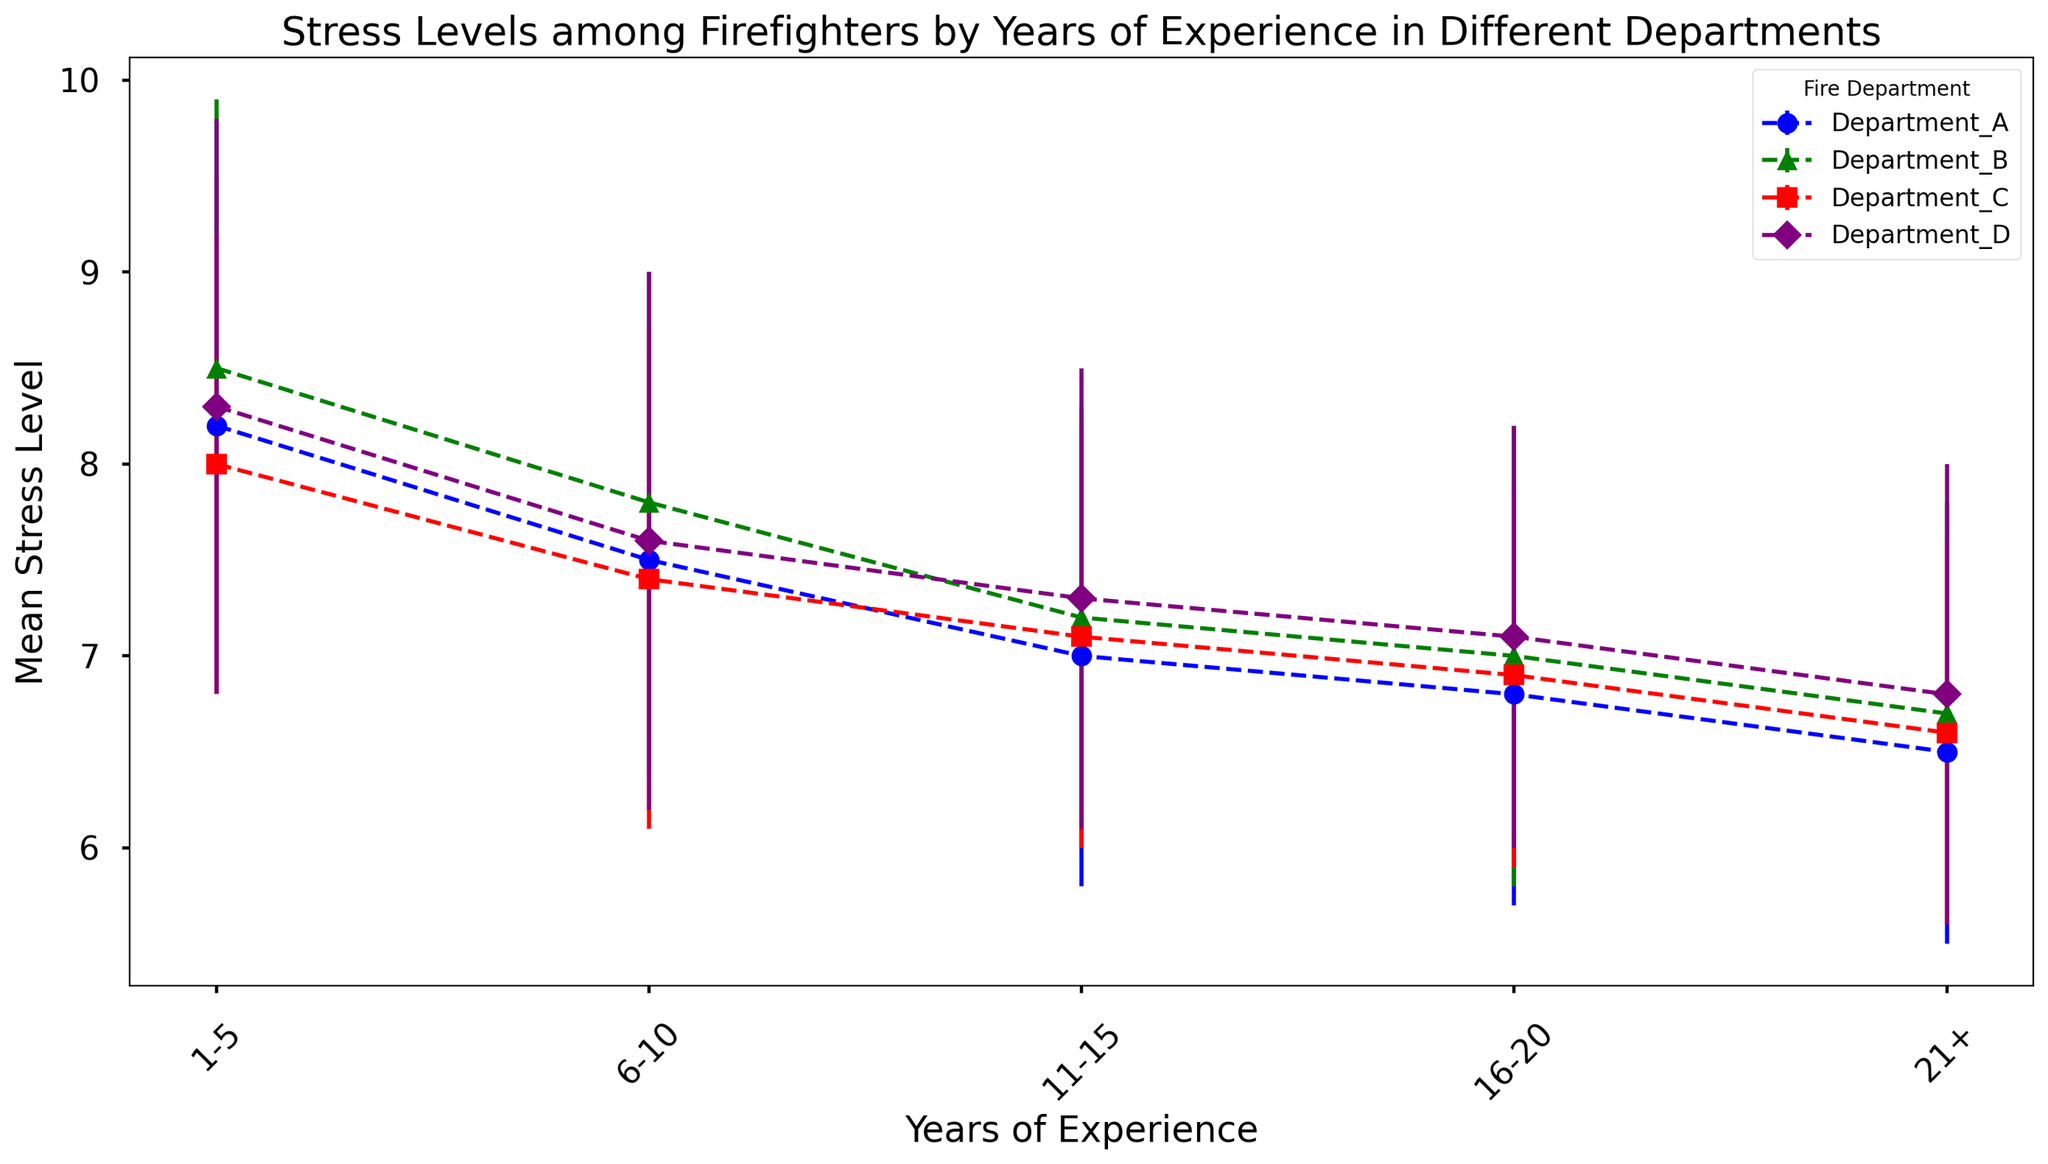How does the stress level of firefighters in Department A change with their years of experience? By looking at the trend in the data for Department A, the mean stress levels decrease from 8.2 to 6.5 as years of experience increase from 1-5 to 21+.
Answer: It decreases How does Department B's stress level for firefighters with 1-5 years of experience compare to Department C's for the same experience range? Compare the mean stress levels in the 1-5 years of experience category between the two departments: Department B has 8.5, while Department C has 8.0.
Answer: Department B's is higher For firefighters with 21+ years of experience, which department shows the lowest average stress level? Compare the mean stress levels for firefighters with 21+ years of experience across all departments. Department A has 6.5, Department B 6.7, Department C 6.6, and Department D 6.8.
Answer: Department A What is the difference in mean stress levels between the 1-5 years and 21+ years experience categories for Department D? Take the mean stress level for 1-5 years (8.3) and subtract the mean stress level for 21+ years (6.8) for Department D. 8.3 - 6.8 = 1.5.
Answer: 1.5 Which department exhibits the most significant decrease in stress levels from the 1-5 year range to the 21+ year range? Calculate the difference between the mean stress levels for 1-5 years and 21+ years of experience for each department. Department A: 8.2 - 6.5 = 1.7, Department B: 8.5 - 6.7 = 1.8, Department C: 8.0 - 6.6 = 1.4, Department D: 8.3 - 6.8 = 1.5.
Answer: Department B Is there a general trend of stress levels across all departments as the years of experience increase? Observe all departments' trends as years of experience increase; mean stress levels decrease in each case.
Answer: Yes, it decreases Which department has the highest variation in stress levels for firefighters with 1-5 years of experience? Compare the standard deviations of stress levels for 1-5 years of experience across all departments: Department A has 1.3, Department B has 1.4, Department C has 1.2, and Department D has 1.5.
Answer: Department D Is the stress level for firefighters with 6-10 years of experience in Department D higher or lower than in Department A? Look at the mean stress levels for firefighters with 6-10 years of experience: Department D is 7.6, while Department A is 7.5.
Answer: Higher Which department has the smallest standard deviation for stress levels among firefighters with 21+ years of experience? Compare the standard deviations for stress levels for the 21+ years experience category across all departments: Department A has 1.0, Department B has 1.1, Department C has 1.0, and Department D has 1.2.
Answer: Department A and C (tie) How does the variability in stress levels (standard deviation) change with years of experience in Department C? Compare the standard deviations for each experience category in Department C: 1-5 years (1.2), 6-10 (1.3), 11-15 (1.1), 16-20 (1.0), 21+ (1.0).
Answer: Generally decreases 